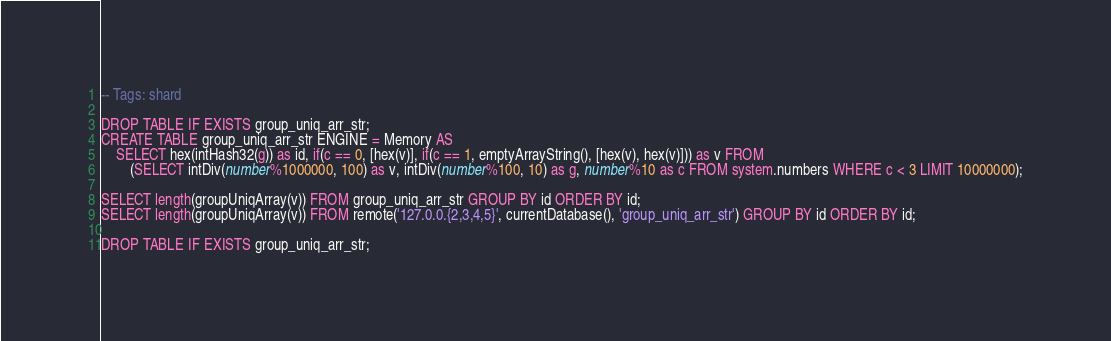<code> <loc_0><loc_0><loc_500><loc_500><_SQL_>-- Tags: shard

DROP TABLE IF EXISTS group_uniq_arr_str;
CREATE TABLE group_uniq_arr_str ENGINE = Memory AS
    SELECT hex(intHash32(g)) as id, if(c == 0, [hex(v)], if(c == 1, emptyArrayString(), [hex(v), hex(v)])) as v FROM
        (SELECT intDiv(number%1000000, 100) as v, intDiv(number%100, 10) as g, number%10 as c FROM system.numbers WHERE c < 3 LIMIT 10000000);

SELECT length(groupUniqArray(v)) FROM group_uniq_arr_str GROUP BY id ORDER BY id;
SELECT length(groupUniqArray(v)) FROM remote('127.0.0.{2,3,4,5}', currentDatabase(), 'group_uniq_arr_str') GROUP BY id ORDER BY id;

DROP TABLE IF EXISTS group_uniq_arr_str;
</code> 